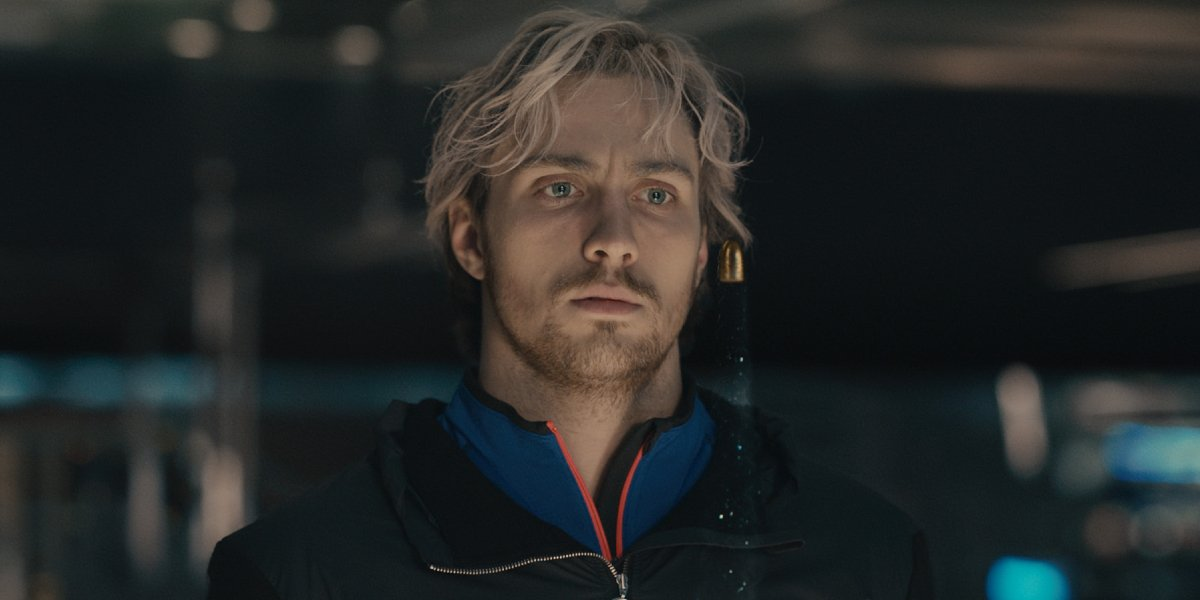What if the man is meeting a secret agent? Write a realistic short response. The man’s serious expression gives way to a slight nod as a figure emerges from the shadows, identifying themselves briefly with a code word. With a subtle exchange of documents, barely noticeable in the dim light, the meeting concludes quickly. The man remains where he is, scanning the area for any signs of surveillance before fading back into the crowd. 